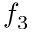Convert formula to latex. <formula><loc_0><loc_0><loc_500><loc_500>f _ { 3 }</formula> 